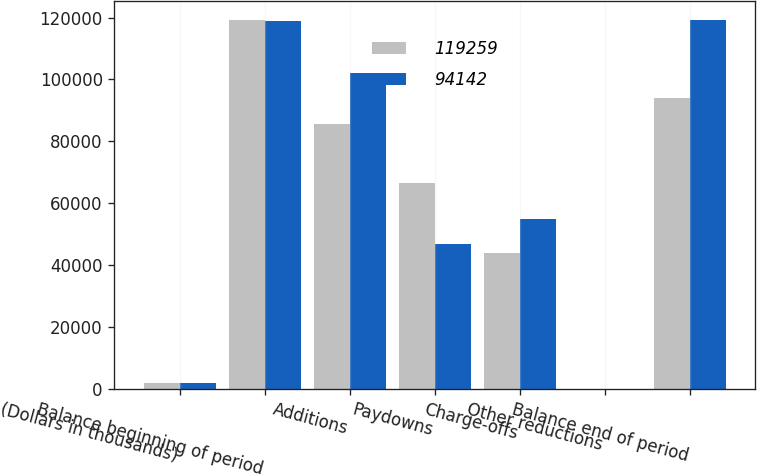Convert chart. <chart><loc_0><loc_0><loc_500><loc_500><stacked_bar_chart><ecel><fcel>(Dollars in thousands)<fcel>Balance beginning of period<fcel>Additions<fcel>Paydowns<fcel>Charge-offs<fcel>Other reductions<fcel>Balance end of period<nl><fcel>119259<fcel>2018<fcel>119259<fcel>85499<fcel>66660<fcel>43857<fcel>99<fcel>94142<nl><fcel>94142<fcel>2017<fcel>118979<fcel>102183<fcel>46825<fcel>55076<fcel>2<fcel>119259<nl></chart> 